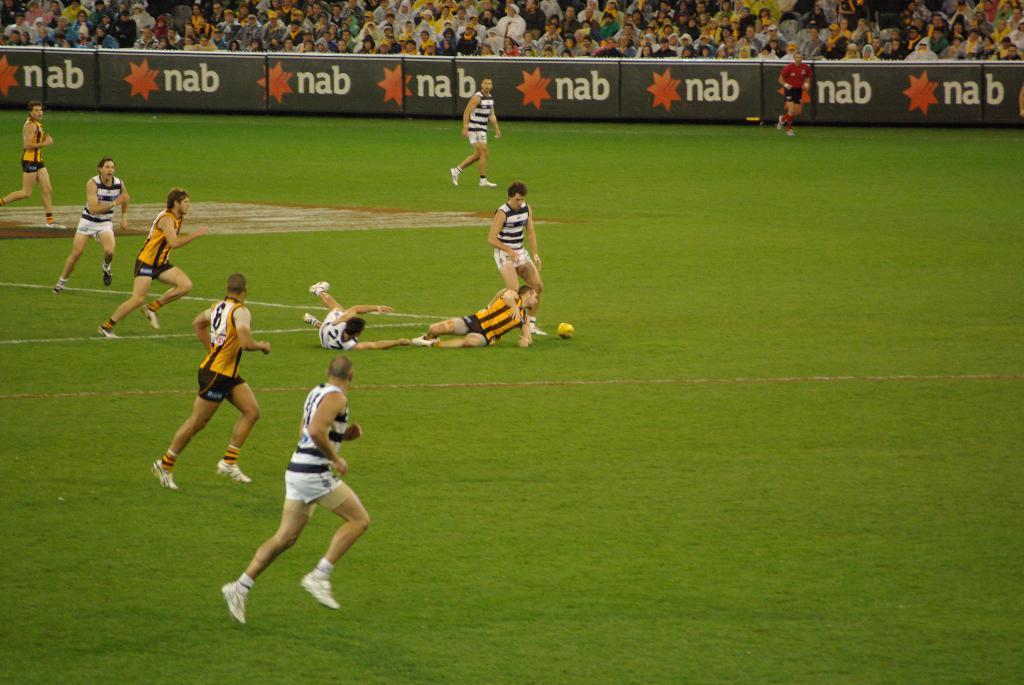Please provide a concise description of this image. In the center of the image we can see one ball and a few people are running and they are in different costumes. In the background, we can see a few boards with some text on it. And we can see a few people are sitting. 